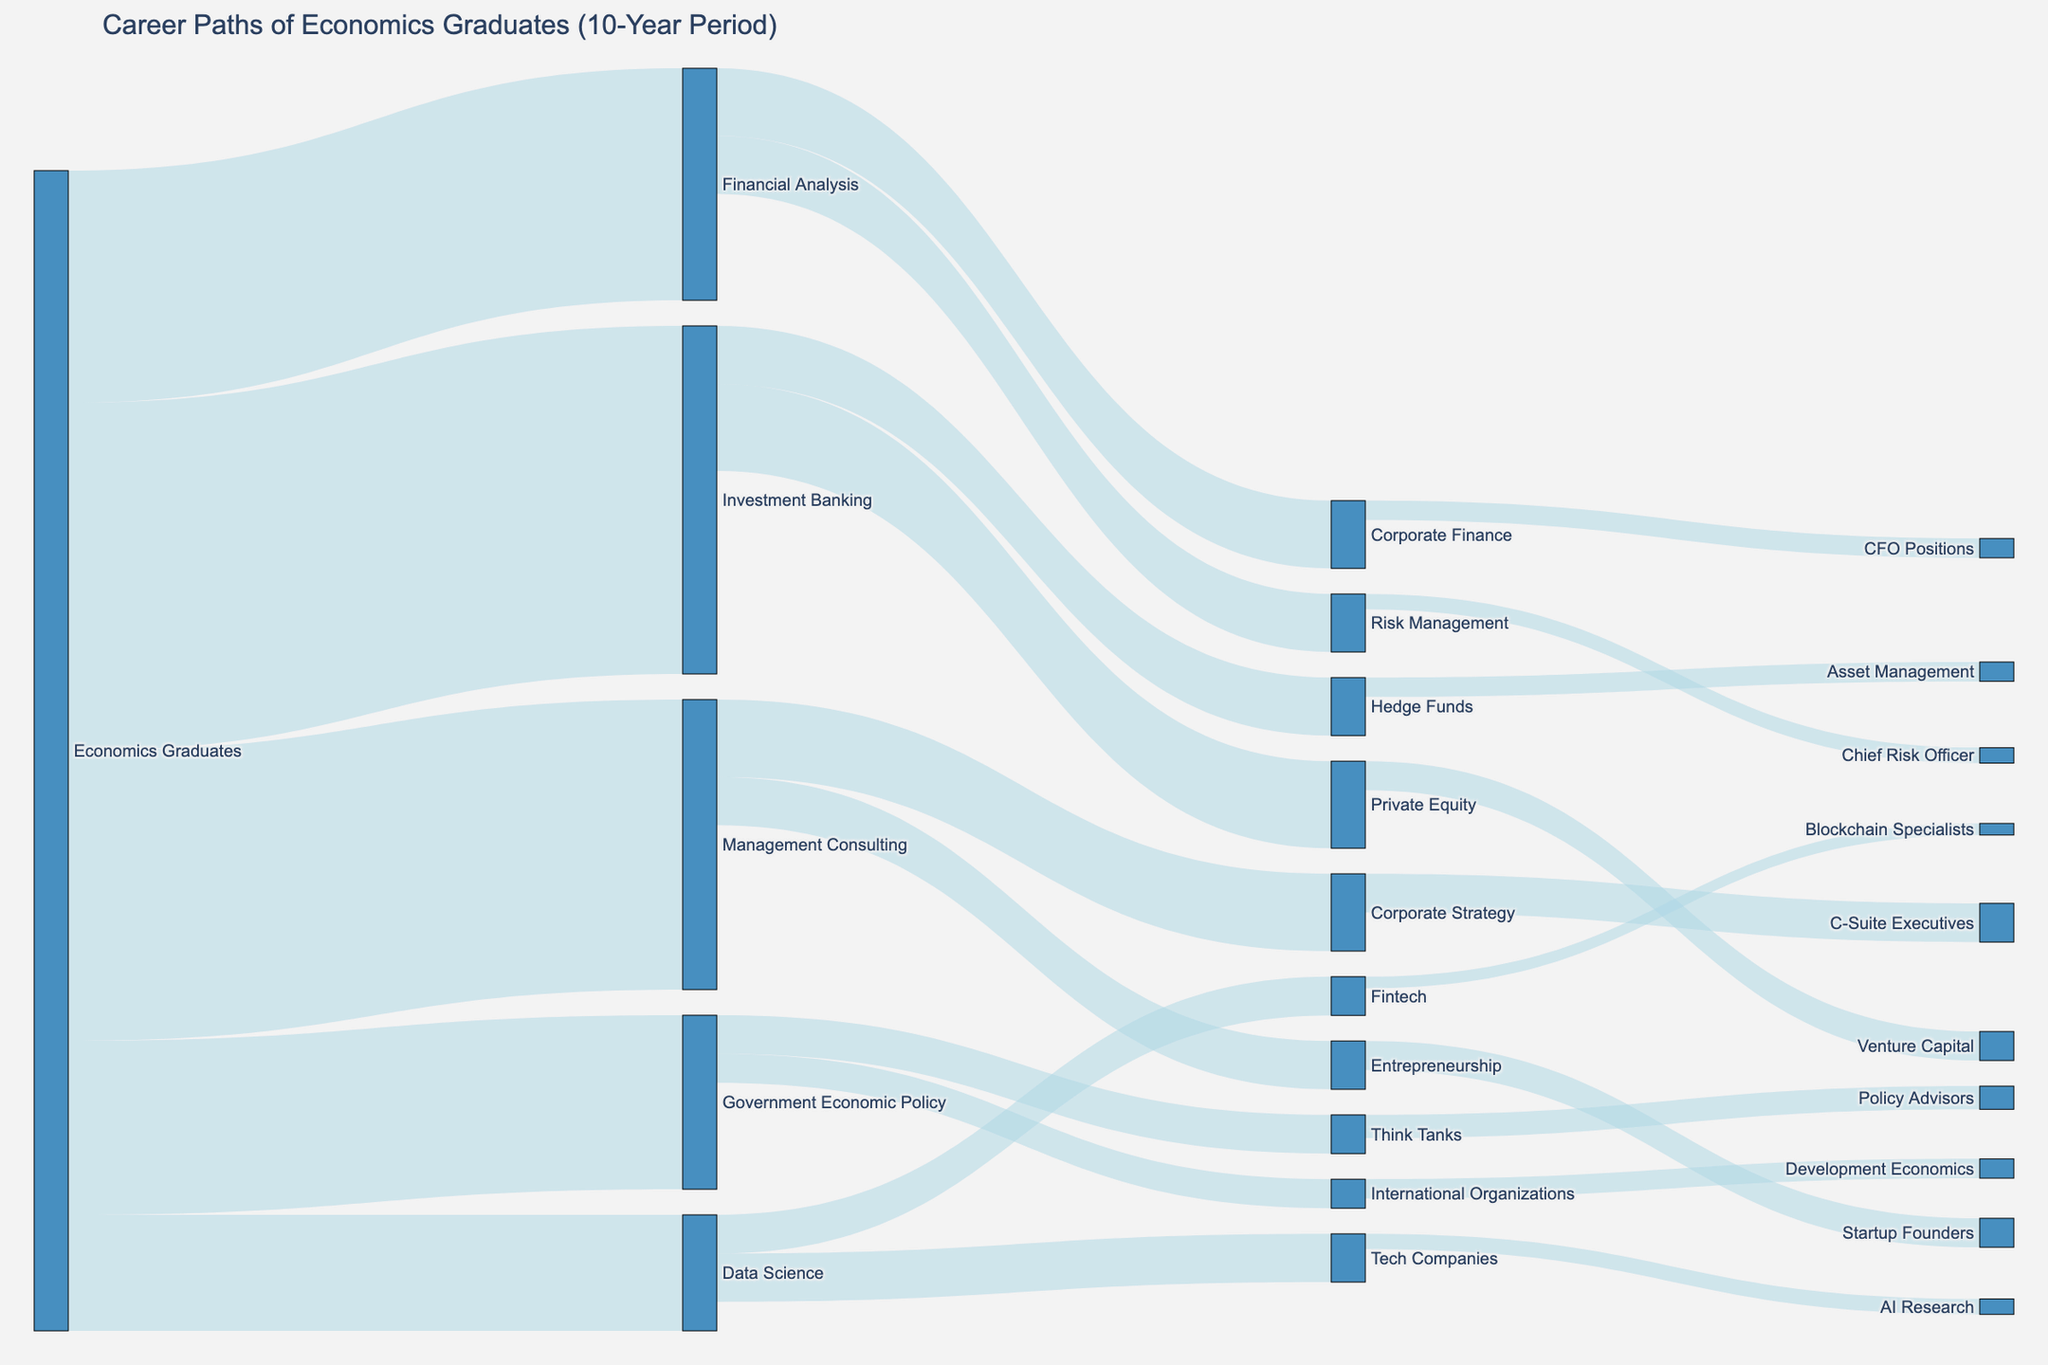What's the title of the figure? The title of the figure is typically located at the top of the diagram. In this case, it should be clearly identified as "Career Paths of Economics Graduates (10-Year Period)".
Answer: Career Paths of Economics Graduates (10-Year Period) Based on the diagram, which career path has the highest number of economics graduates initially? By observing the size of the flows from the "Economics Graduates" node, we can see that "Investment Banking" has the largest flow, indicating the highest number of economics graduates initially.
Answer: Investment Banking How many graduates transitioned from Investment Banking to Private Equity? The flow connecting "Investment Banking" to "Private Equity" represents this transition. The diagram should have a specific value labeled on this flow.
Answer: 45 How many total graduates moved into Data Science roles directly after graduating in Economics? Look at the flow from "Economics Graduates" to "Data Science" in the diagram. The value on this flow represents the total number of graduates.
Answer: 60 What is the combined number of graduates who transitioned into both Venture Capital and Asset Management from Investment Banking? Add the values of the flows from "Investment Banking" to "Venture Capital" and "Hedge Funds", and then add "Hedge Funds" to "Asset Management". 45 (Private Equity) + 15 (Venture Capital) + 30 (Hedge Funds) + 10 (Asset Management).
Answer: 55 What is the difference between the number of graduates in Management Consulting compared to Financial Analysis right after graduating? Find the values on the flows from "Economics Graduates" to "Management Consulting" and to "Financial Analysis", respectively, and subtract the latter from the former. 150 (Management Consulting) - 120 (Financial Analysis).
Answer: 30 Which career path has the least number of graduates who transitioned from Government Economic Policy? Observe the flows originating from "Government Economic Policy". The one with the smallest value represents the least number of transitions.
Answer: International Organizations What role do graduates in Corporate Strategy commonly transition into, according to the diagram? Look for the flow moving out from "Corporate Strategy" to identify the next common role. The one with a non-zero value is the common transition path.
Answer: C-Suite Executives Based on the diagram, which career path has a higher inflow of graduates: AI Research or Blockchain Specialists? Compare the inflow values to "AI Research" and "Blockchain Specialists". "Tech Companies" to "AI Research" and "Fintech" to "Blockchain Specialists".
Answer: AI Research What is the total number of graduates that transitioned into think tanks and policy advisor roles combined? Add the values of the flows from "Government Economic Policy" to "Think Tanks" and from "Think Tanks" to "Policy Advisors". 20 (Think Tanks) + 12 (Policy Advisors).
Answer: 32 